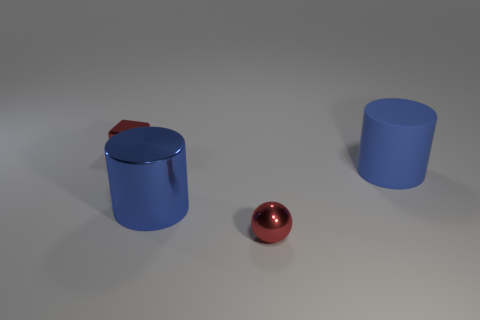How many green objects are tiny metallic cubes or rubber cylinders?
Ensure brevity in your answer.  0. What is the shape of the red object that is to the left of the big shiny thing?
Provide a succinct answer. Cube. There is a thing that is the same size as the red metallic sphere; what color is it?
Provide a short and direct response. Red. There is a matte object; is it the same shape as the red object on the left side of the big blue metal cylinder?
Make the answer very short. No. What material is the red object that is right of the small red object on the left side of the big blue cylinder left of the tiny red ball?
Offer a very short reply. Metal. What number of large objects are brown matte balls or red metallic balls?
Offer a very short reply. 0. How many other objects are there of the same size as the blue rubber object?
Your answer should be very brief. 1. There is a big blue object in front of the big matte thing; is its shape the same as the big rubber object?
Ensure brevity in your answer.  Yes. The other object that is the same shape as the blue metal object is what color?
Give a very brief answer. Blue. Are there any other things that have the same shape as the blue shiny thing?
Keep it short and to the point. Yes. 